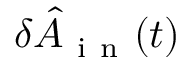<formula> <loc_0><loc_0><loc_500><loc_500>\delta \hat { A } _ { i n } ( t )</formula> 